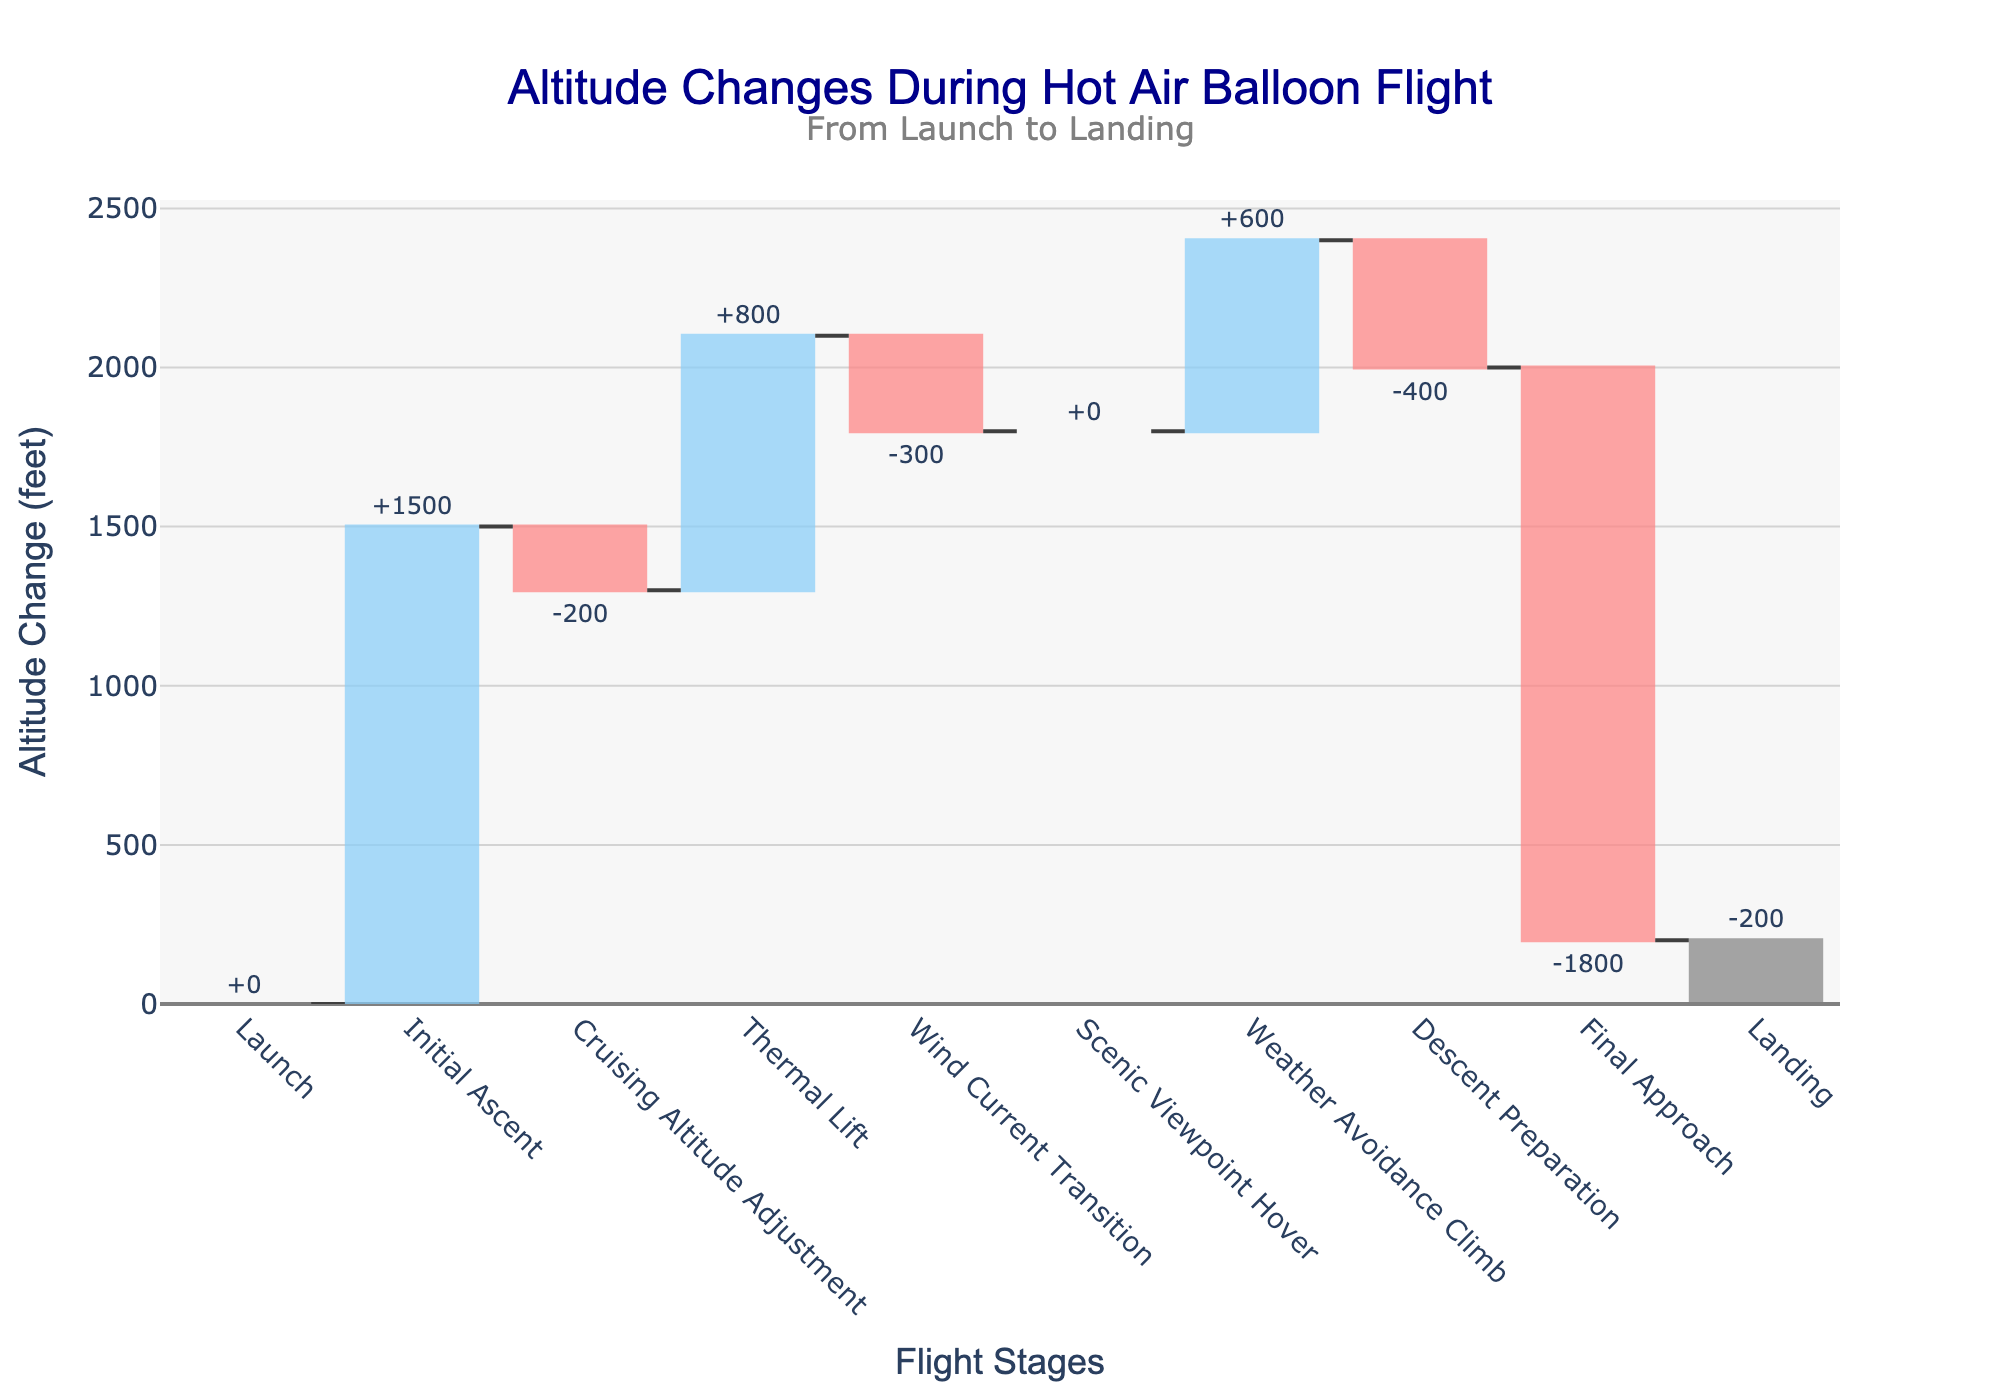What is the title of the chart? The title is text that appears prominently above the chart, indicating what the chart is about. In this case, the title is located at the top center.
Answer: Altitude Changes During Hot Air Balloon Flight What is the total change in altitude from launch to landing? Sum all the altitude change values provided in the stages. In the data: 0 + 1500 - 200 + 800 - 300 + 0 + 600 - 400 - 1800 - 200 = 0 feet. Therefore, the total change is 0.
Answer: 0 feet Which stage has the highest positive altitude change? Identify the stage with the largest positive value in "Altitude Change (feet)". This can be found by comparing the values. The highest positive change is +1500 feet during the Initial Ascent.
Answer: Initial Ascent How much does the altitude change during the descent phases? Identify all the stages related to descent and sum their altitude changes. The Descent Preparation is -400 feet, Final Approach is -1800 feet, and Landing is -200 feet. Sum these: -400 + (-1800) + (-200) = -2400 feet.
Answer: -2400 feet What is the altitude after the Thermal Lift stage? To find the cumulative altitude after the Thermal Lift, add the changes from the Launch to the Thermal Lift: 0 + 1500 - 200 + 800 = 2100 feet.
Answer: 2100 feet Which stages involve a negative altitude change? Look for stages with negative values in the "Altitude Change (feet)" column. These stages are Cruising Altitude Adjustment (-200), Wind Current Transition (-300), Descent Preparation (-400), Final Approach (-1800), and Landing (-200).
Answer: Cruising Altitude Adjustment, Wind Current Transition, Descent Preparation, Final Approach, Landing How does the scenic viewpoint hover affect the altitude? Identify the altitude change at the Scenic Viewpoint Hover stage, which is listed as 0, indicating no change in altitude.
Answer: 0 (no change) Compare the altitude change during Initial Ascent versus Final Approach. Which is greater? Compare the values: Initial Ascent is +1500 feet and Final Approach is -1800 feet. The magnitude of Final Approach is greater:
Answer: Final Approach What's the cumulative altitude at the weather avoidance climb stage? Add up all altitude changes from Launch up to Weather Avoidance Climb: 0 + 1500 - 200 + 800 - 300 + 0 + 600 = 2400 feet.
Answer: 2400 feet 